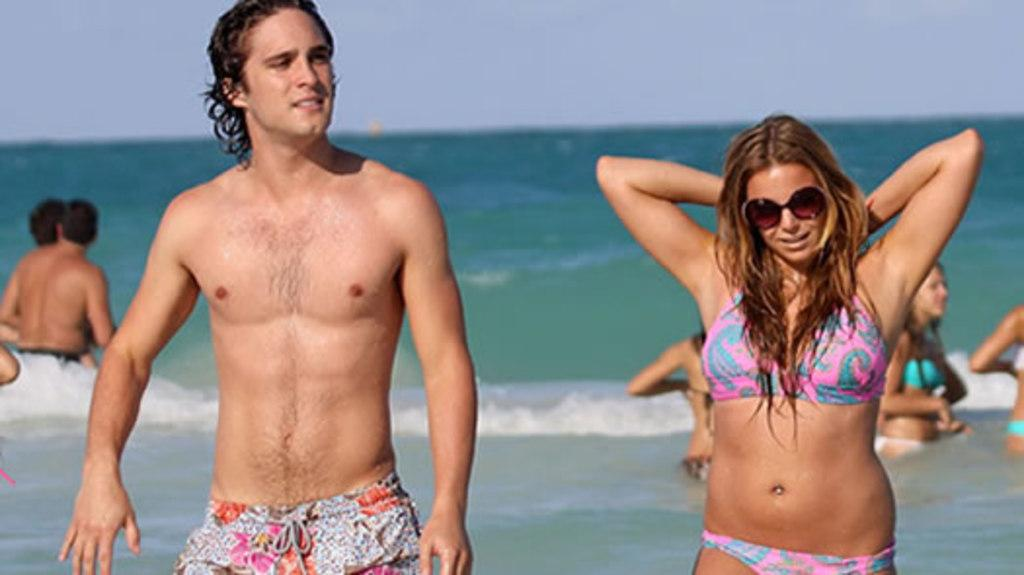How many people are present in the image? There are two people, a man and a woman, present in the image. What is the woman wearing that is specific to the scene? The woman is wearing goggles. What is the primary element visible in the image? There is water visible in the image. What are the other persons in the image doing? The other persons are in the water. What can be seen in the background of the image? The sky is visible in the background of the image. What type of organization is the woman representing in the image? There is no indication in the image that the woman is representing any organization. Can you tell me how many stockings the man is wearing in the image? There is no mention of stockings in the image, and the man's legs are not visible. 